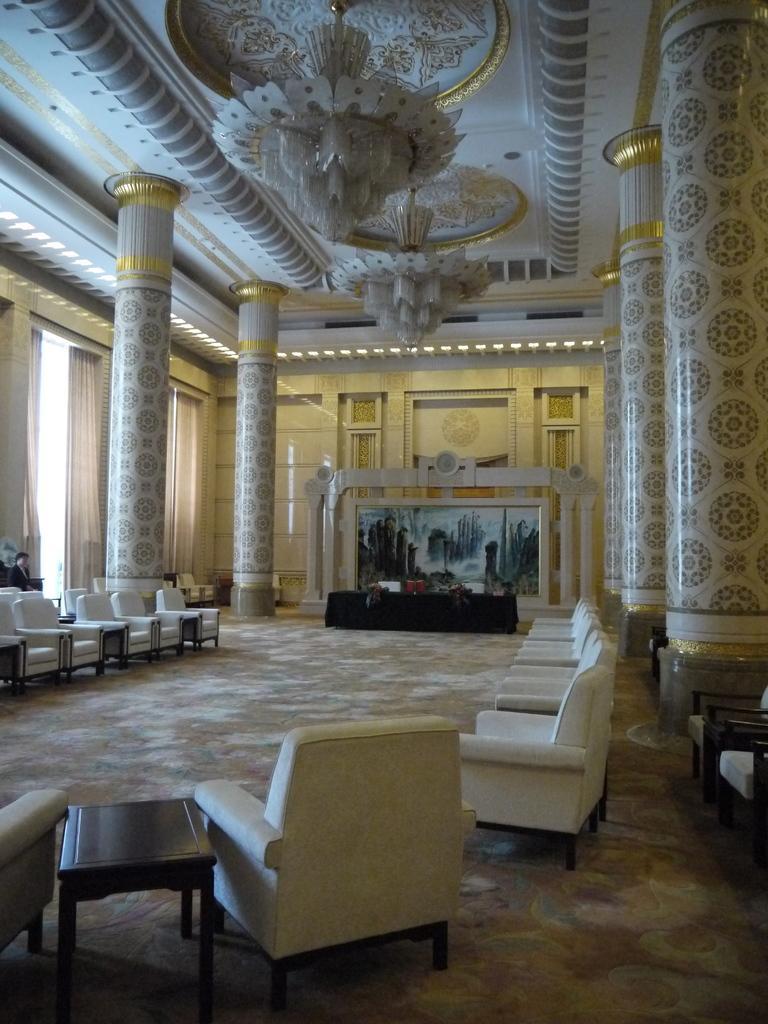Could you give a brief overview of what you see in this image? The picture is taken in a hall. In the foreground of picture there are couches, table, chairs, and a mat. In the center of the picture there are chairs, table and a painting to the wall. On the left there are pillars, person and chair, curtains and windows. On the right there are pillars. At the top there are chandeliers. 